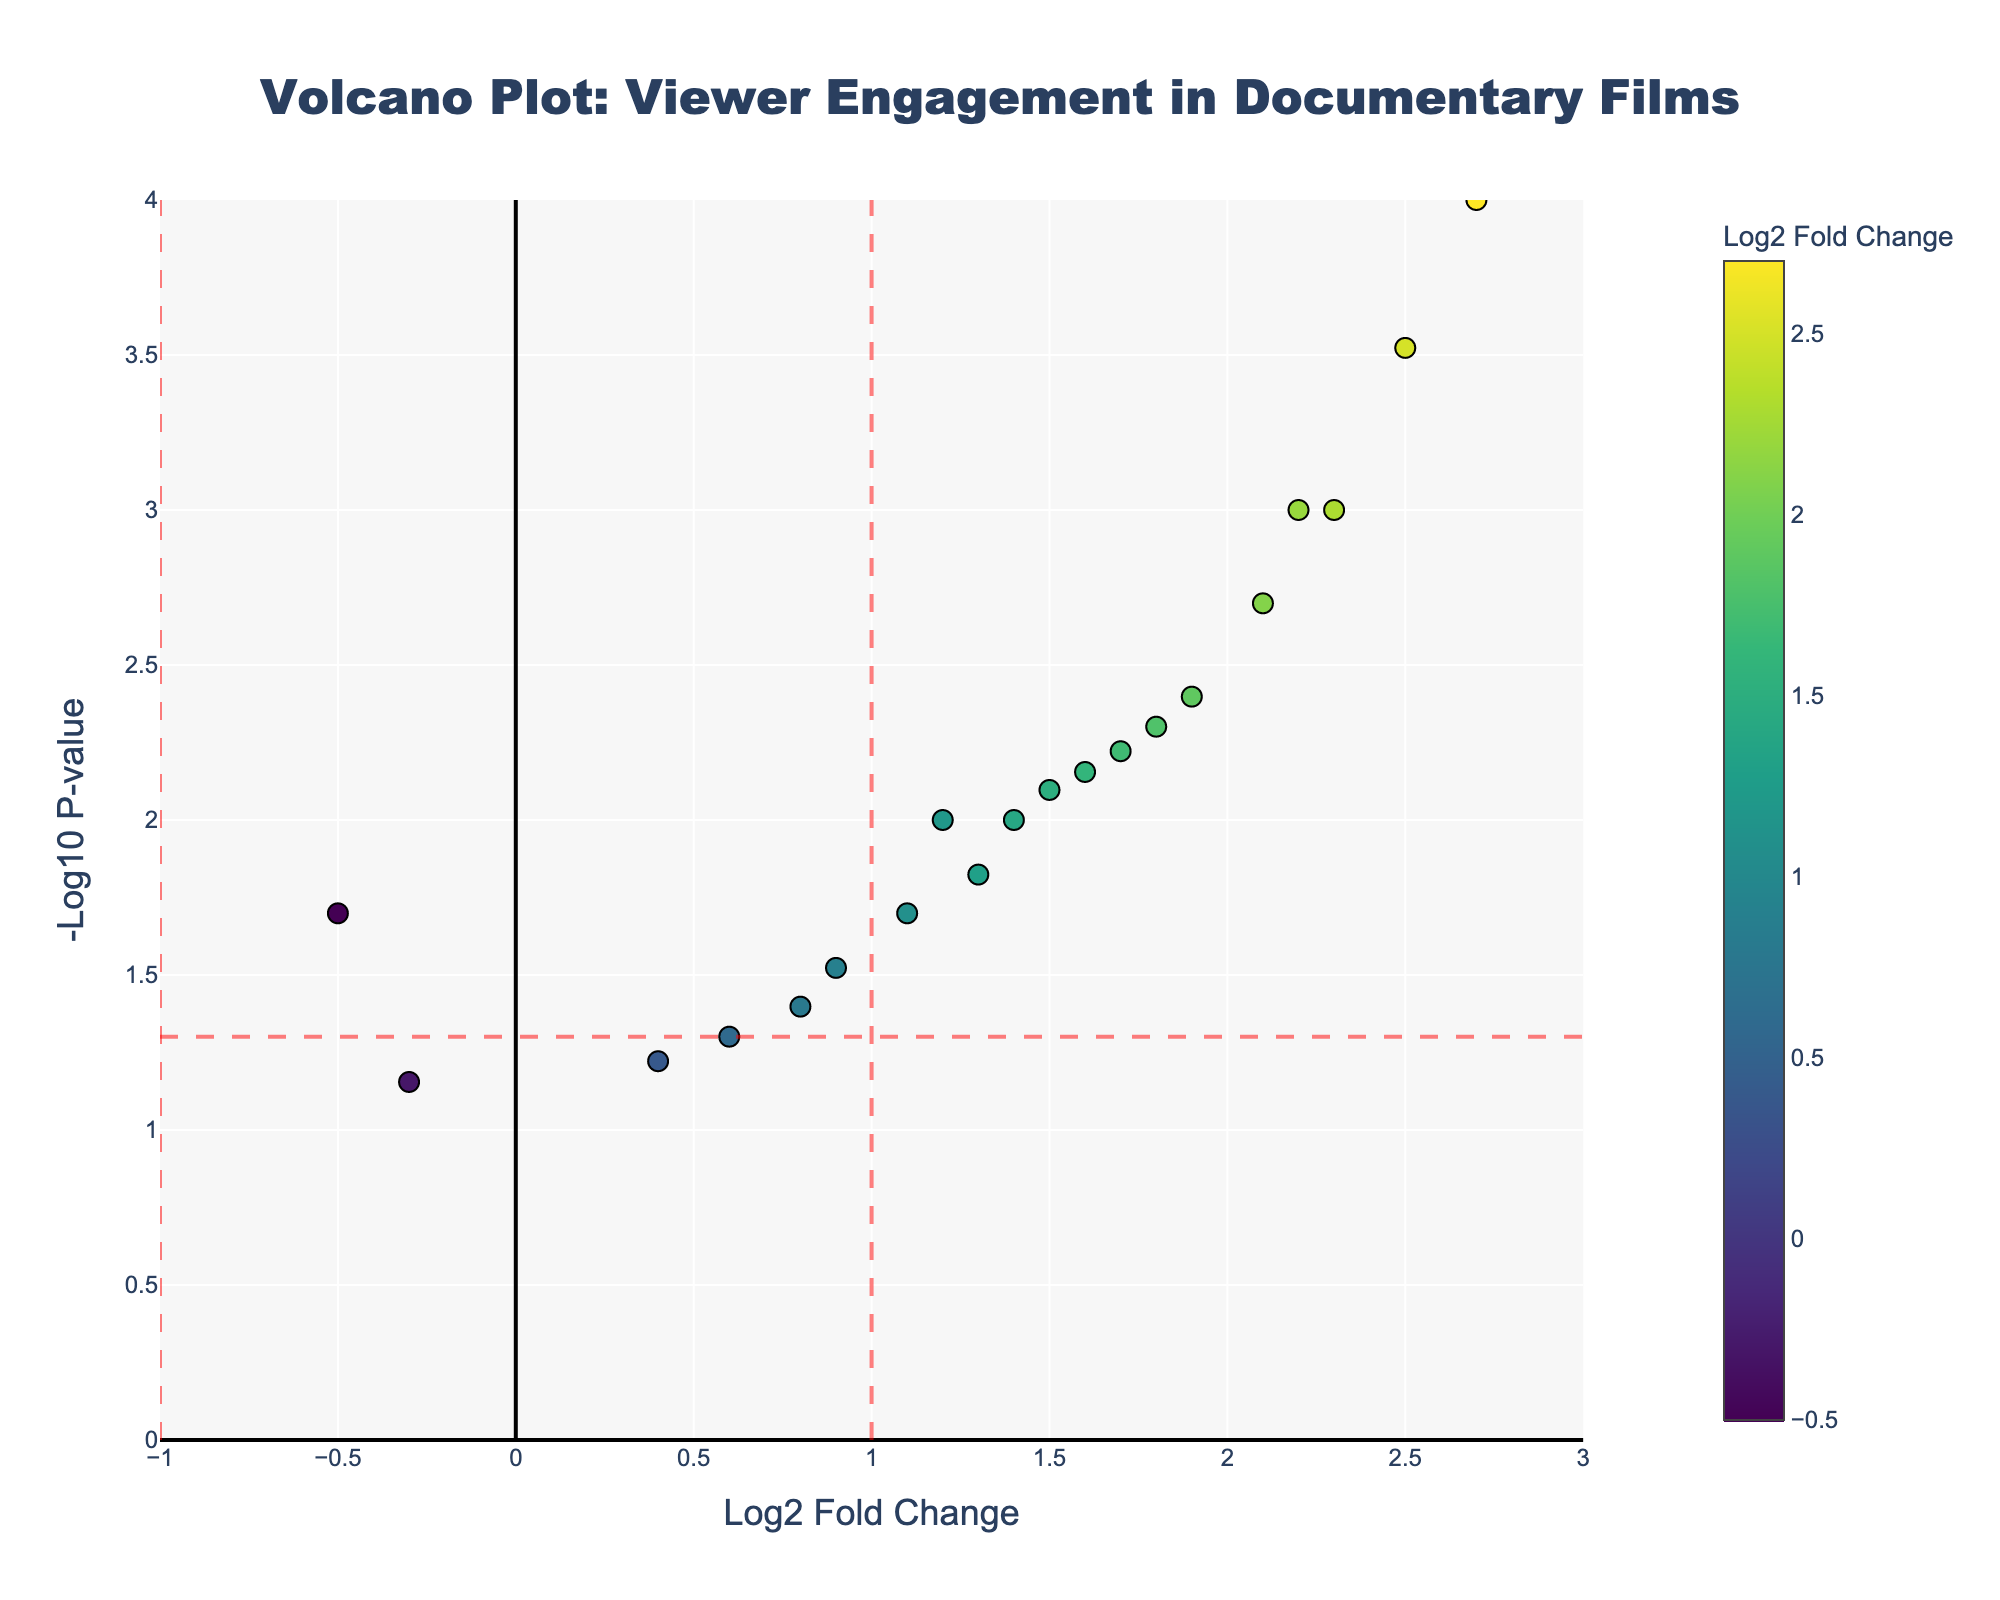What is the title of the plot? The title is displayed at the top of the plot in a larger and bold font.
Answer: Volcano Plot: Viewer Engagement in Documentary Films What are the x-axis and y-axis labels? The x-axis label is located at the bottom of the plot and reads 'Log2 Fold Change', and the y-axis label is located at the left side of the plot and reads '-Log10 P-value'.
Answer: Log2 Fold Change, -Log10 P-value How many films are represented in the plot? Each dot represents a film, so by counting the dots you can determine the number of films.
Answer: 20 Which film has the highest log2 fold change? Look for the point farthest to the right on the x-axis and check its hover text for the film title.
Answer: Fahrenheit 9/11 Which film has the lowest -log10 p-value? Look for the point lowest on the y-axis and check its hover text for the film title.
Answer: Jiro Dreams of Sushi What are the significance thresholds indicated on the plot? The vertical red dashed lines at x = 1 and x = -1 mark the log2 fold change thresholds, and the horizontal red dashed line at y = 1.301 marks the -log10(p-value) threshold (p = 0.05).
Answer: x = ±1, y = 1.301 Which films have a significant increase in viewer engagement above the fold-change threshold? Look for points above the horizontal threshold line and to the right of the vertical x = 1 line; check their hover texts.
Answer: The Act of Killing, Fahrenheit 9/11, Free Solo, An Inconvenient Truth, Blackfish, The Last Dance, Super Size Me, Amy, The Social Dilemma Which films have a significant decrease in viewer engagement below the fold-change threshold? Look for points above the horizontal threshold line and to the left of the vertical x = -1 line; however, there are no such points shown.
Answer: None Are there any films that are barely below the -log10 p-value threshold? Look for points just below the horizontal red dashed line at y = 1.301 and check their hover texts.
Answer: The Fog of War What is the log2 fold change and p-value of 'March of the Penguins'? Find the point corresponding to 'March of the Penguins' from the hover text and read the values mentioned.
Answer: -0.5, 0.02 